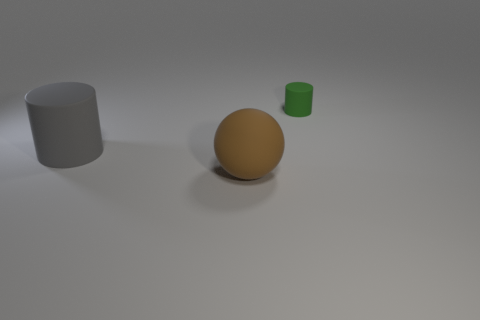Is there anything else that is the same size as the green rubber cylinder?
Your answer should be very brief. No. What color is the cylinder that is the same material as the small thing?
Give a very brief answer. Gray. There is a cylinder on the right side of the cylinder that is to the left of the thing that is on the right side of the large brown object; how big is it?
Your response must be concise. Small. Is the number of purple blocks less than the number of brown things?
Offer a very short reply. Yes. What is the color of the other object that is the same shape as the small green rubber object?
Make the answer very short. Gray. Is there a sphere that is in front of the matte object right of the brown thing in front of the large gray cylinder?
Give a very brief answer. Yes. Is the shape of the large gray matte thing the same as the brown thing?
Keep it short and to the point. No. Are there fewer brown things on the right side of the large brown matte object than tiny brown matte things?
Make the answer very short. No. There is a matte cylinder that is right of the rubber cylinder that is in front of the cylinder that is behind the large gray rubber cylinder; what is its color?
Offer a very short reply. Green. How many metal things are green cylinders or big brown objects?
Ensure brevity in your answer.  0. 